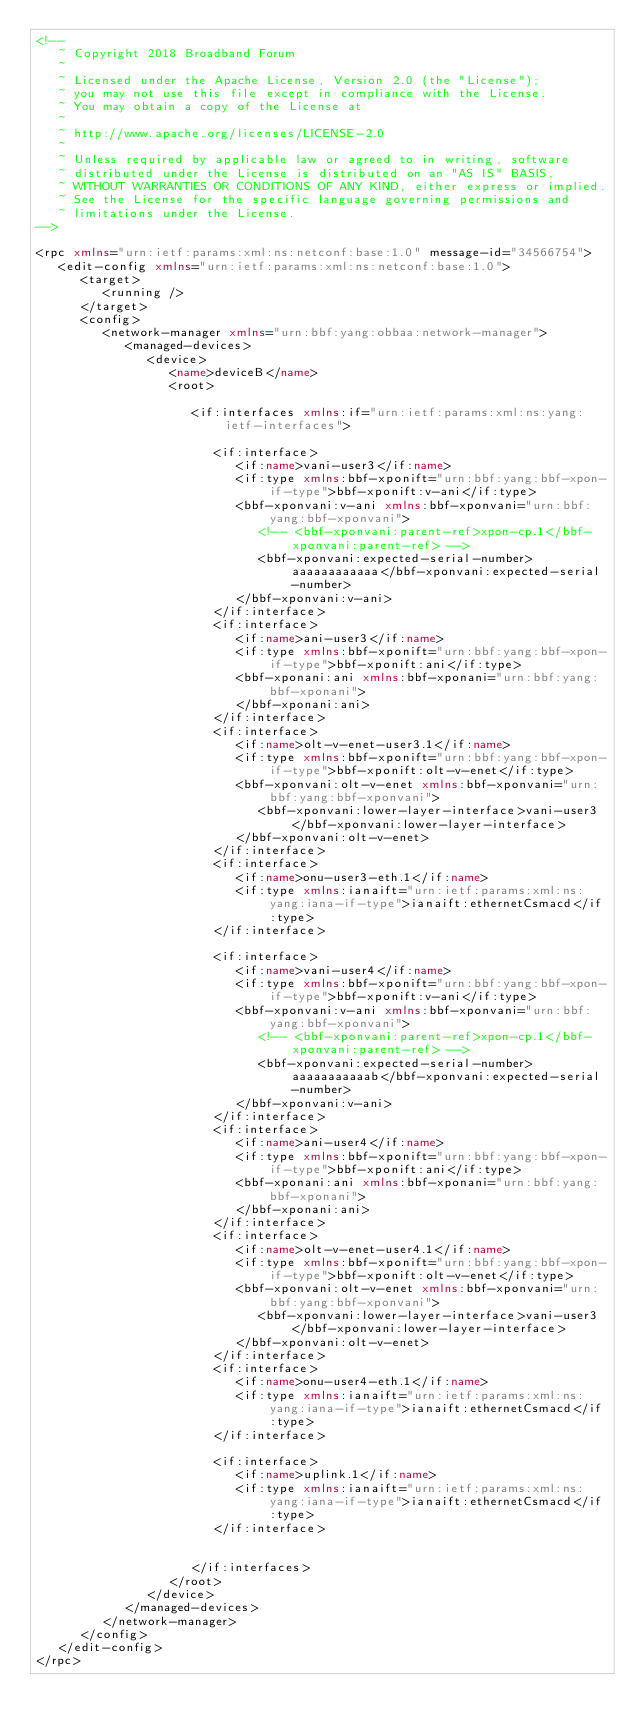<code> <loc_0><loc_0><loc_500><loc_500><_XML_><!--
   ~ Copyright 2018 Broadband Forum
   ~
   ~ Licensed under the Apache License, Version 2.0 (the "License");
   ~ you may not use this file except in compliance with the License.
   ~ You may obtain a copy of the License at
   ~
   ~ http://www.apache.org/licenses/LICENSE-2.0
   ~
   ~ Unless required by applicable law or agreed to in writing, software
   ~ distributed under the License is distributed on an "AS IS" BASIS,
   ~ WITHOUT WARRANTIES OR CONDITIONS OF ANY KIND, either express or implied.
   ~ See the License for the specific language governing permissions and
   ~ limitations under the License.
-->

<rpc xmlns="urn:ietf:params:xml:ns:netconf:base:1.0" message-id="34566754">
   <edit-config xmlns="urn:ietf:params:xml:ns:netconf:base:1.0">
      <target>
         <running />
      </target>
      <config>
         <network-manager xmlns="urn:bbf:yang:obbaa:network-manager">
            <managed-devices>
               <device>
                  <name>deviceB</name>
                  <root>

                     <if:interfaces xmlns:if="urn:ietf:params:xml:ns:yang:ietf-interfaces">
                     
                        <if:interface>
                           <if:name>vani-user3</if:name>
                           <if:type xmlns:bbf-xponift="urn:bbf:yang:bbf-xpon-if-type">bbf-xponift:v-ani</if:type>
                           <bbf-xponvani:v-ani xmlns:bbf-xponvani="urn:bbf:yang:bbf-xponvani">
                              <!-- <bbf-xponvani:parent-ref>xpon-cp.1</bbf-xponvani:parent-ref> -->
                              <bbf-xponvani:expected-serial-number>aaaaaaaaaaaa</bbf-xponvani:expected-serial-number>
                           </bbf-xponvani:v-ani>
                        </if:interface>
                        <if:interface>
                           <if:name>ani-user3</if:name>
                           <if:type xmlns:bbf-xponift="urn:bbf:yang:bbf-xpon-if-type">bbf-xponift:ani</if:type>
                           <bbf-xponani:ani xmlns:bbf-xponani="urn:bbf:yang:bbf-xponani">
                           </bbf-xponani:ani>
                        </if:interface>
                        <if:interface>
                           <if:name>olt-v-enet-user3.1</if:name>
                           <if:type xmlns:bbf-xponift="urn:bbf:yang:bbf-xpon-if-type">bbf-xponift:olt-v-enet</if:type>
                           <bbf-xponvani:olt-v-enet xmlns:bbf-xponvani="urn:bbf:yang:bbf-xponvani">
                              <bbf-xponvani:lower-layer-interface>vani-user3</bbf-xponvani:lower-layer-interface>
                           </bbf-xponvani:olt-v-enet>
                        </if:interface>
                        <if:interface>
                           <if:name>onu-user3-eth.1</if:name>
                           <if:type xmlns:ianaift="urn:ietf:params:xml:ns:yang:iana-if-type">ianaift:ethernetCsmacd</if:type>
                        </if:interface>

                        <if:interface>
                           <if:name>vani-user4</if:name>
                           <if:type xmlns:bbf-xponift="urn:bbf:yang:bbf-xpon-if-type">bbf-xponift:v-ani</if:type>
                           <bbf-xponvani:v-ani xmlns:bbf-xponvani="urn:bbf:yang:bbf-xponvani">
                              <!-- <bbf-xponvani:parent-ref>xpon-cp.1</bbf-xponvani:parent-ref> -->
                              <bbf-xponvani:expected-serial-number>aaaaaaaaaaab</bbf-xponvani:expected-serial-number>
                           </bbf-xponvani:v-ani>
                        </if:interface>
                        <if:interface>
                           <if:name>ani-user4</if:name>
                           <if:type xmlns:bbf-xponift="urn:bbf:yang:bbf-xpon-if-type">bbf-xponift:ani</if:type>
                           <bbf-xponani:ani xmlns:bbf-xponani="urn:bbf:yang:bbf-xponani">
                           </bbf-xponani:ani>
                        </if:interface>
                        <if:interface>
                           <if:name>olt-v-enet-user4.1</if:name>
                           <if:type xmlns:bbf-xponift="urn:bbf:yang:bbf-xpon-if-type">bbf-xponift:olt-v-enet</if:type>
                           <bbf-xponvani:olt-v-enet xmlns:bbf-xponvani="urn:bbf:yang:bbf-xponvani">
                              <bbf-xponvani:lower-layer-interface>vani-user3</bbf-xponvani:lower-layer-interface>
                           </bbf-xponvani:olt-v-enet>
                        </if:interface>
                        <if:interface>
                           <if:name>onu-user4-eth.1</if:name>
                           <if:type xmlns:ianaift="urn:ietf:params:xml:ns:yang:iana-if-type">ianaift:ethernetCsmacd</if:type>
                        </if:interface>

                        <if:interface>
                           <if:name>uplink.1</if:name>
                           <if:type xmlns:ianaift="urn:ietf:params:xml:ns:yang:iana-if-type">ianaift:ethernetCsmacd</if:type>
                        </if:interface>


                     </if:interfaces>
                  </root>
               </device>
            </managed-devices>
         </network-manager>
      </config>
   </edit-config>
</rpc>
</code> 